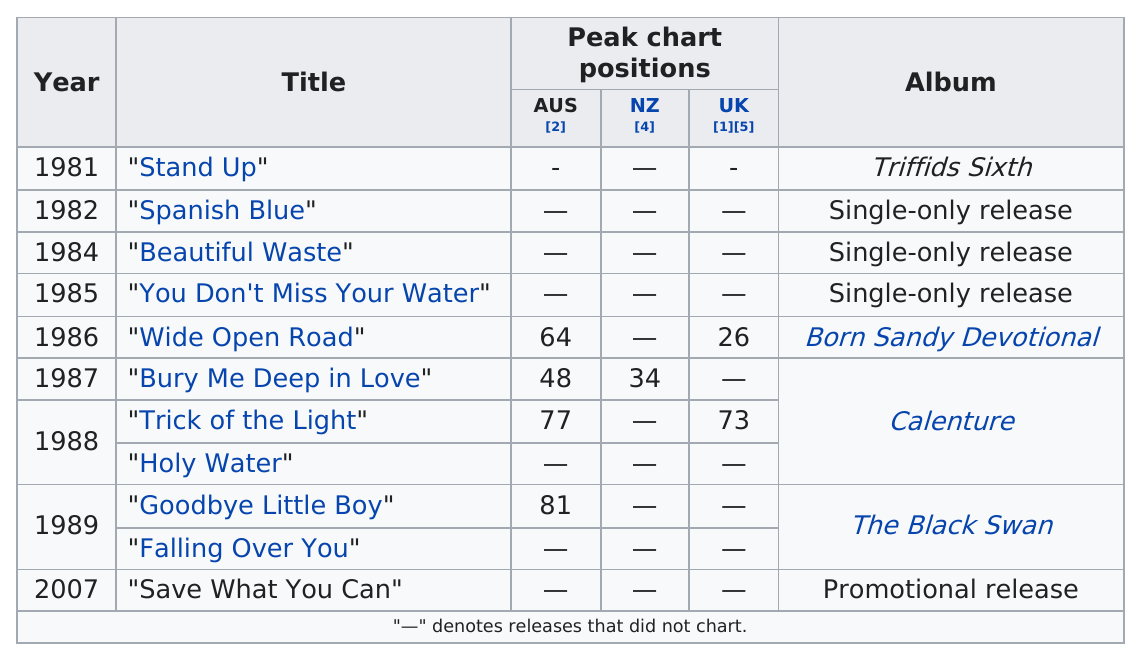List a handful of essential elements in this visual. Out of the number of singles that had a peak chart position below 60, we found that there were only two. The track with the highest peak position is "Wide Open Road. In the year 1986, the track "Wide Open Road" was released. After the single "Wide Open Road," the next single was "Bury Me Deep in Love. It is known that the most recent New Zealand single to appear on the charts is titled 'Bury Me Deep in Love'. 